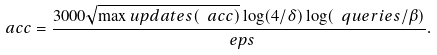<formula> <loc_0><loc_0><loc_500><loc_500>\ a c c = \frac { 3 0 0 0 \sqrt { \max u p d a t e s ( \ a c c ) } \log ( 4 / \delta ) \log ( \ q u e r i e s / \beta ) } { \ e p s } .</formula> 